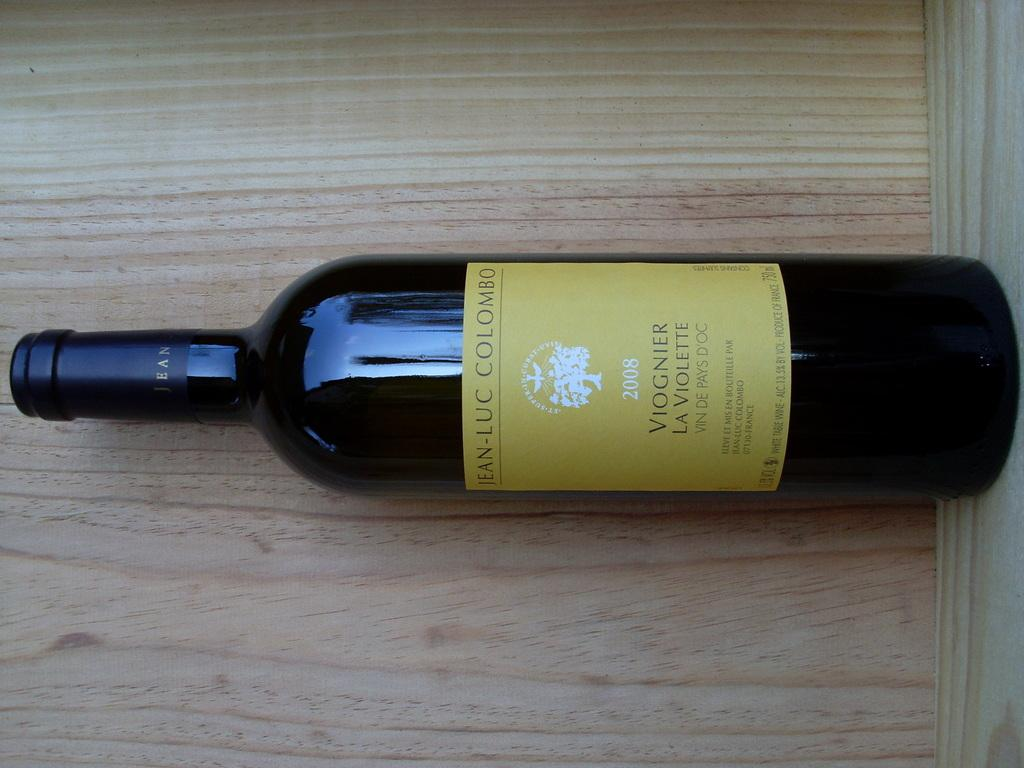Provide a one-sentence caption for the provided image. A bottle of Viognier La Violette from 2008 lies on the board. 